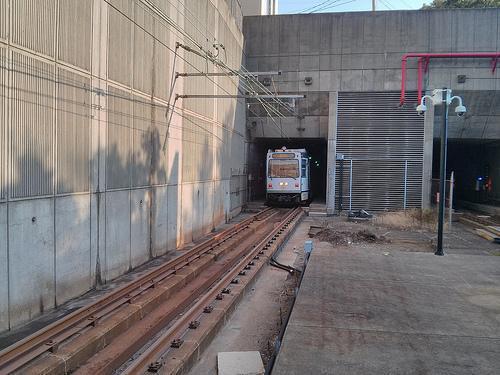How many trains?
Give a very brief answer. 1. 